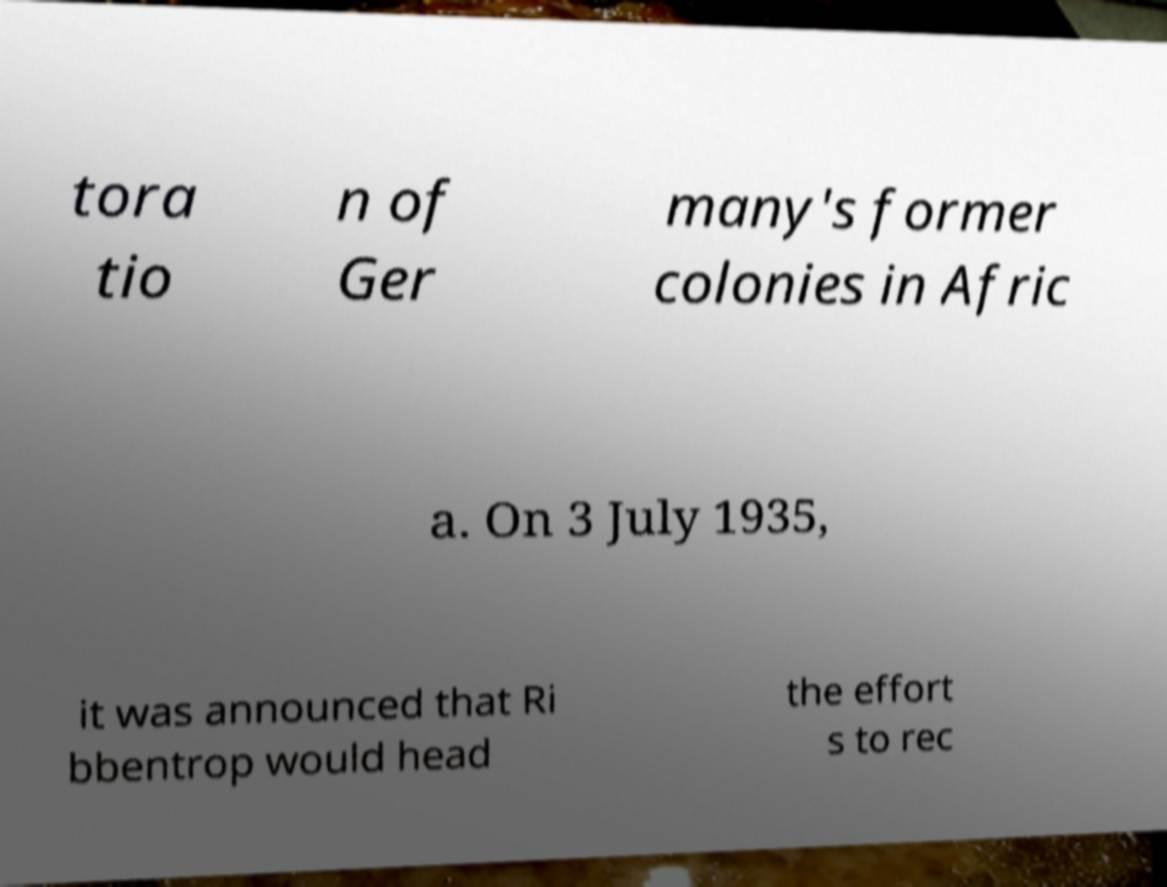What messages or text are displayed in this image? I need them in a readable, typed format. tora tio n of Ger many's former colonies in Afric a. On 3 July 1935, it was announced that Ri bbentrop would head the effort s to rec 